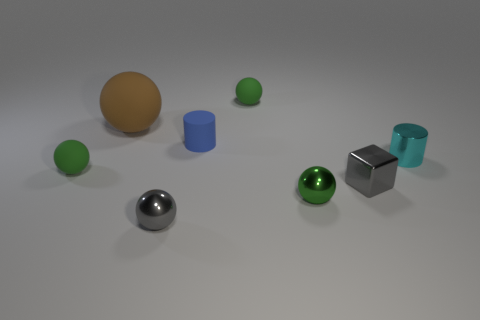How many small metallic spheres have the same color as the block?
Make the answer very short. 1. How many things are either blocks or big balls?
Give a very brief answer. 2. What shape is the blue object that is the same size as the cyan cylinder?
Make the answer very short. Cylinder. How many small objects are both to the right of the blue matte thing and behind the green metallic ball?
Provide a succinct answer. 3. There is a green thing behind the cyan cylinder; what is it made of?
Offer a very short reply. Rubber. The cylinder that is made of the same material as the gray ball is what size?
Your answer should be compact. Small. Is the size of the sphere that is behind the brown ball the same as the gray object that is left of the green metallic ball?
Offer a very short reply. Yes. What is the material of the cyan cylinder that is the same size as the green shiny object?
Your response must be concise. Metal. There is a small green ball that is both behind the small green shiny ball and to the right of the small matte cylinder; what is its material?
Ensure brevity in your answer.  Rubber. Are there any large green blocks?
Offer a very short reply. No. 